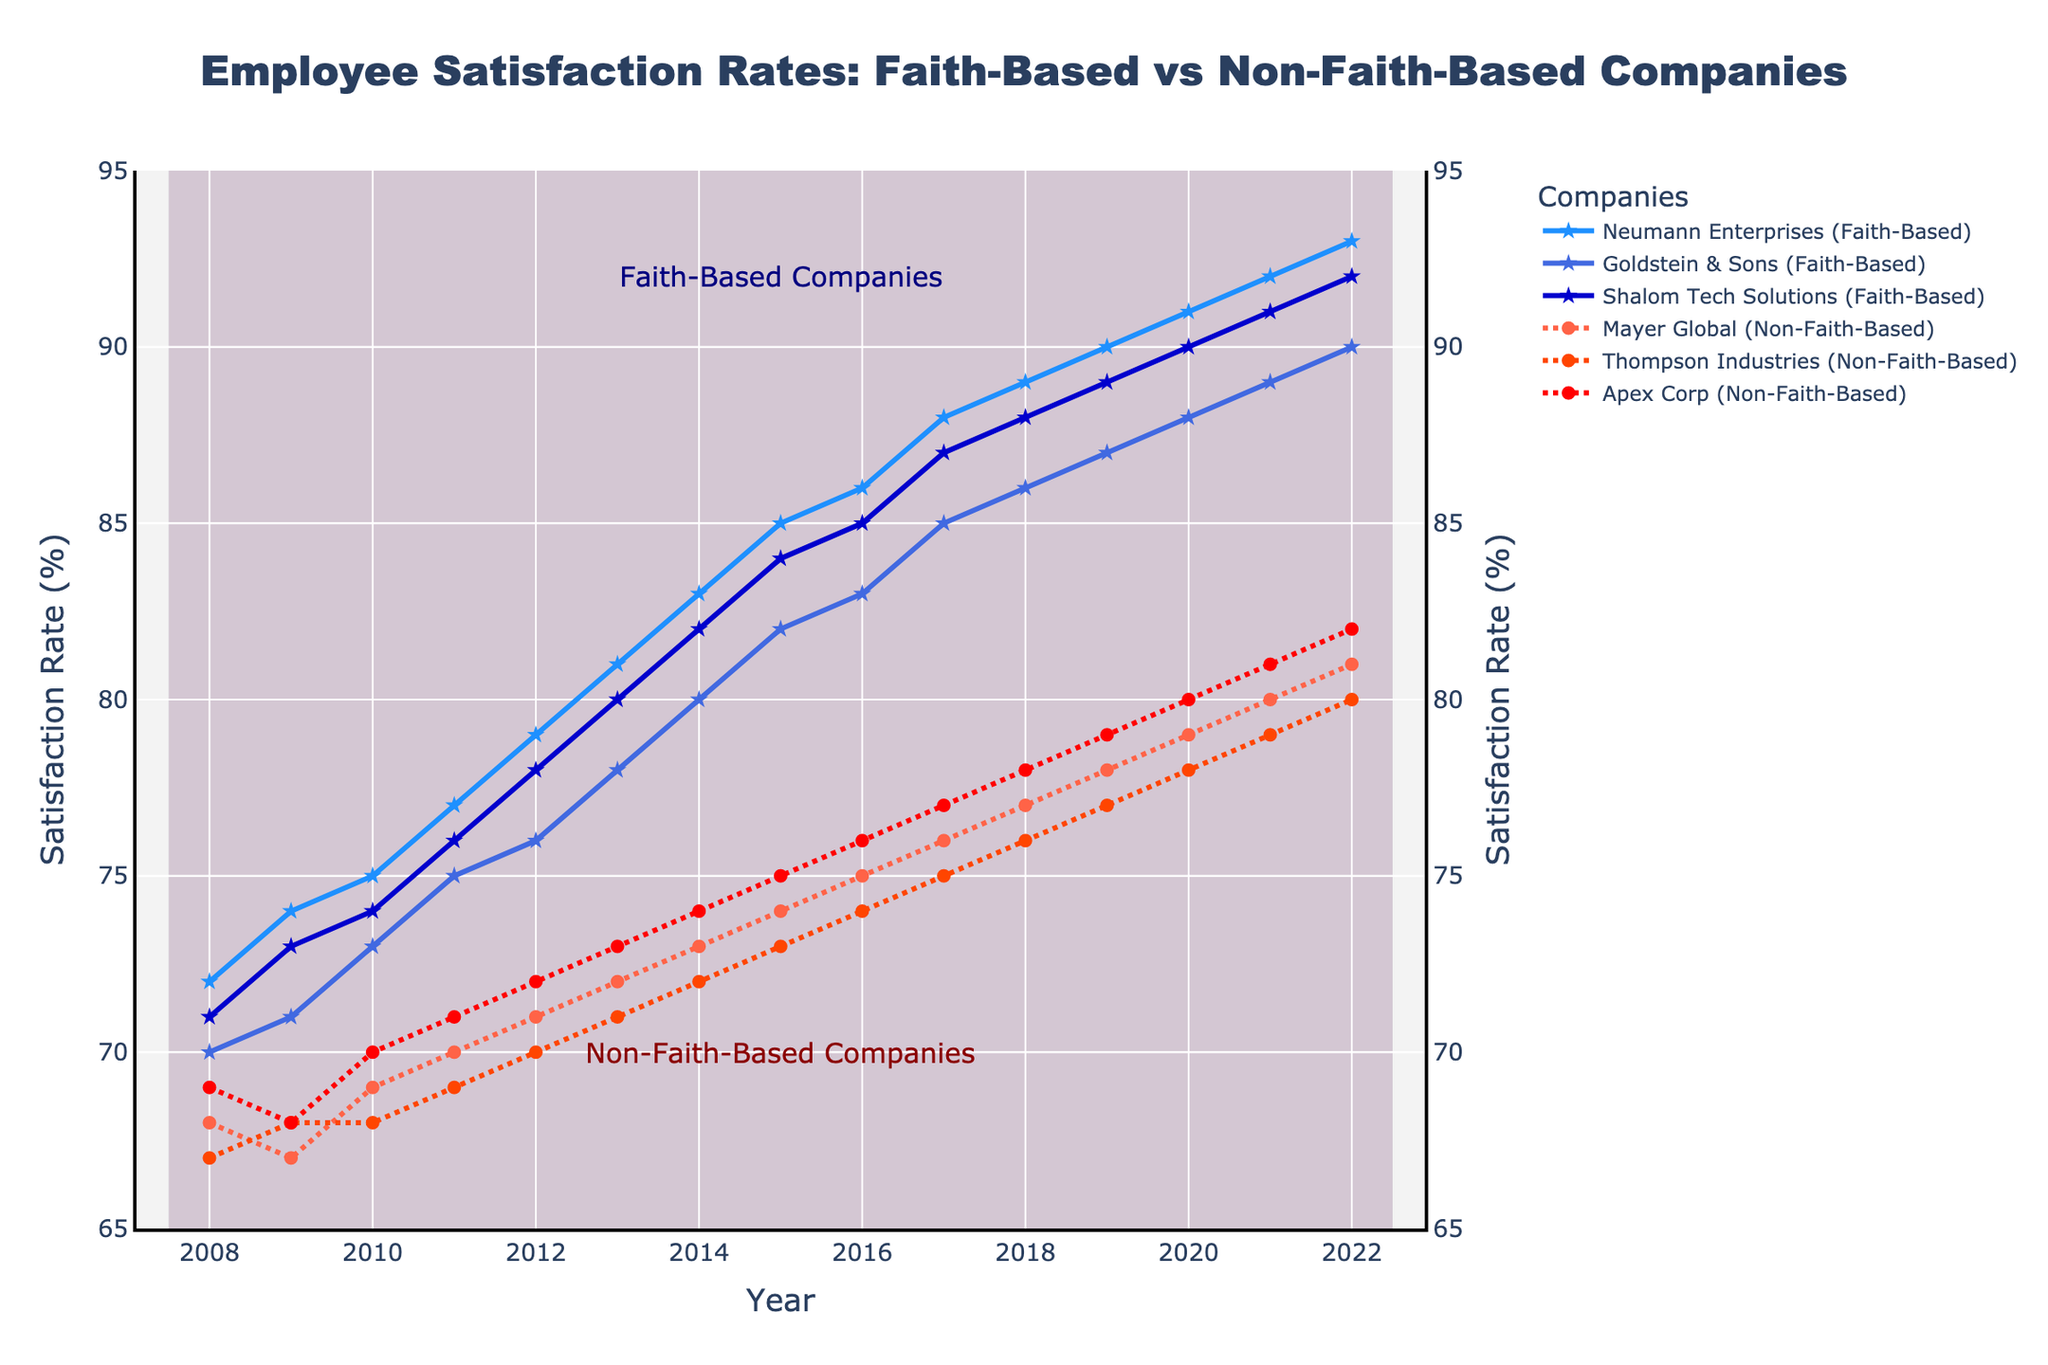What is the general trend of employee satisfaction rates for faith-based companies between 2008 and 2022? The trend of employee satisfaction rates for faith-based companies increases from approximately 70% in 2008 to over 90% in 2022, showing a consistent upward movement throughout the years.
Answer: Upward trend How does the employee satisfaction rate of Neumann Enterprises compare to Mayer Global in 2020? In 2020, Neumann Enterprises has an employee satisfaction rate of 91%, while Mayer Global has a satisfaction rate of 79%. Comparing these rates, Neumann Enterprises has a higher satisfaction rate.
Answer: Neumann Enterprises is higher Which year shows the greatest difference in satisfaction rates between faith-based and non-faith-based companies? To find the greatest difference, we calculate the satisfaction rates difference for each year. It is evident that in 2022, the satisfaction differences are the largest with faith-based companies around 93% and non-faith-based companies about 81%.
Answer: 2022 What is the average employee satisfaction rate for Thompson Industries over the 15-year period? By summing the satisfaction rates of Thompson Industries from 2008 to 2022 (67+68+68+69+70+71+72+73+74+75+76+77+78+79+80) and dividing by 15, we get (1077/15). The average satisfaction rate is thus approximately 71.8%.
Answer: Approximately 71.8% Which company shows the steadiest growth in employee satisfaction rates over 15 years? By comparing the satisfaction rates visually across the years for each company, Shalom Tech Solutions has a consistently steady growth from 71% in 2008 to 92% in 2022 without any dips or sharp increases.
Answer: Shalom Tech Solutions Which year did Apex Corp achieve an employee satisfaction rate equal to the faith-based companies' rates of the initial years? Apex Corp shows a satisfaction rate of 71% in 2013, which is equivalent to the faith-based companies' rates around 2008.
Answer: 2013 How do employee satisfaction rates in 2010 for faith-based companies compare to non-faith-based companies? In 2010, faith-based companies' satisfaction rates are 75%, 73%, and 74% while non-faith-based companies show 69%, 68%, and 70%. Faith-based companies generally have higher rates compared to non-faith-based ones.
Answer: Faith-based rates are higher What is the maximum satisfaction rate achieved by any company over the 15 years? By evaluating the data visually, the maximum satisfaction rate achieved is 93%, reached by Neumann Enterprises at the year 2022.
Answer: 93% Which faith-based company had the highest increase in employee satisfaction rate between 2008 and 2022? By comparing satisfaction rate in 2008 and 2022, Neumann Enterprises increased from 72% to 93%, which is a 21% increase, the highest among faith-based companies.
Answer: Neumann Enterprises What is the median satisfaction rate for Mayer Global throughout the years? Mayer Global has the following rates: 68, 67, 69, 70, 71, 72, 73, 74, 75, 76, 77, 78, 79, 80, 81. The median value is the middle value in the sorted list, which is 73.
Answer: 73 